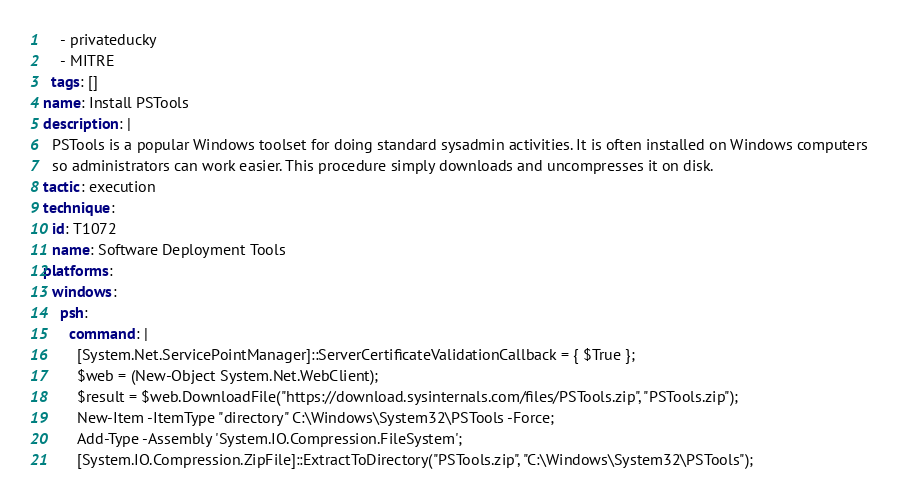<code> <loc_0><loc_0><loc_500><loc_500><_YAML_>    - privateducky
    - MITRE
  tags: []
name: Install PSTools
description: |
  PSTools is a popular Windows toolset for doing standard sysadmin activities. It is often installed on Windows computers
  so administrators can work easier. This procedure simply downloads and uncompresses it on disk.
tactic: execution
technique:
  id: T1072
  name: Software Deployment Tools
platforms:
  windows:
    psh:
      command: |
        [System.Net.ServicePointManager]::ServerCertificateValidationCallback = { $True };
        $web = (New-Object System.Net.WebClient);
        $result = $web.DownloadFile("https://download.sysinternals.com/files/PSTools.zip", "PSTools.zip");
        New-Item -ItemType "directory" C:\Windows\System32\PSTools -Force;
        Add-Type -Assembly 'System.IO.Compression.FileSystem';
        [System.IO.Compression.ZipFile]::ExtractToDirectory("PSTools.zip", "C:\Windows\System32\PSTools");
</code> 